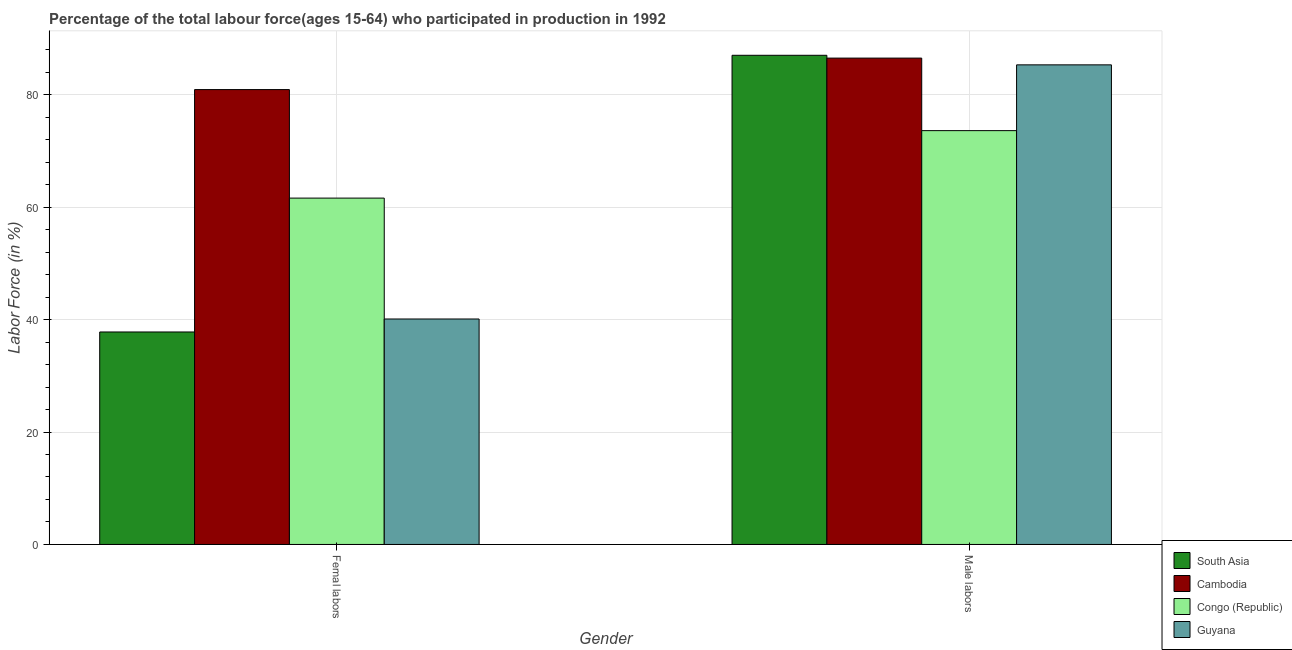How many different coloured bars are there?
Keep it short and to the point. 4. How many groups of bars are there?
Your response must be concise. 2. Are the number of bars on each tick of the X-axis equal?
Your response must be concise. Yes. How many bars are there on the 2nd tick from the left?
Your answer should be very brief. 4. What is the label of the 2nd group of bars from the left?
Give a very brief answer. Male labors. What is the percentage of female labor force in South Asia?
Offer a very short reply. 37.79. Across all countries, what is the maximum percentage of male labour force?
Offer a terse response. 87. Across all countries, what is the minimum percentage of female labor force?
Keep it short and to the point. 37.79. In which country was the percentage of male labour force maximum?
Provide a short and direct response. South Asia. In which country was the percentage of female labor force minimum?
Ensure brevity in your answer.  South Asia. What is the total percentage of male labour force in the graph?
Keep it short and to the point. 332.4. What is the difference between the percentage of male labour force in Congo (Republic) and that in Cambodia?
Provide a short and direct response. -12.9. What is the difference between the percentage of female labor force in Cambodia and the percentage of male labour force in Guyana?
Your answer should be very brief. -4.4. What is the average percentage of male labour force per country?
Give a very brief answer. 83.1. What is the difference between the percentage of male labour force and percentage of female labor force in South Asia?
Ensure brevity in your answer.  49.21. What is the ratio of the percentage of female labor force in Congo (Republic) to that in Guyana?
Give a very brief answer. 1.54. Is the percentage of male labour force in South Asia less than that in Cambodia?
Your answer should be very brief. No. In how many countries, is the percentage of male labour force greater than the average percentage of male labour force taken over all countries?
Offer a very short reply. 3. What does the 3rd bar from the left in Femal labors represents?
Ensure brevity in your answer.  Congo (Republic). What does the 2nd bar from the right in Femal labors represents?
Your answer should be very brief. Congo (Republic). Are all the bars in the graph horizontal?
Provide a short and direct response. No. Are the values on the major ticks of Y-axis written in scientific E-notation?
Offer a terse response. No. Does the graph contain any zero values?
Ensure brevity in your answer.  No. How many legend labels are there?
Give a very brief answer. 4. How are the legend labels stacked?
Provide a succinct answer. Vertical. What is the title of the graph?
Provide a succinct answer. Percentage of the total labour force(ages 15-64) who participated in production in 1992. Does "Caribbean small states" appear as one of the legend labels in the graph?
Keep it short and to the point. No. What is the label or title of the Y-axis?
Keep it short and to the point. Labor Force (in %). What is the Labor Force (in %) of South Asia in Femal labors?
Your answer should be compact. 37.79. What is the Labor Force (in %) of Cambodia in Femal labors?
Give a very brief answer. 80.9. What is the Labor Force (in %) in Congo (Republic) in Femal labors?
Your response must be concise. 61.6. What is the Labor Force (in %) in Guyana in Femal labors?
Make the answer very short. 40.1. What is the Labor Force (in %) of South Asia in Male labors?
Provide a short and direct response. 87. What is the Labor Force (in %) of Cambodia in Male labors?
Offer a terse response. 86.5. What is the Labor Force (in %) in Congo (Republic) in Male labors?
Provide a short and direct response. 73.6. What is the Labor Force (in %) of Guyana in Male labors?
Give a very brief answer. 85.3. Across all Gender, what is the maximum Labor Force (in %) in South Asia?
Offer a terse response. 87. Across all Gender, what is the maximum Labor Force (in %) in Cambodia?
Your response must be concise. 86.5. Across all Gender, what is the maximum Labor Force (in %) of Congo (Republic)?
Provide a succinct answer. 73.6. Across all Gender, what is the maximum Labor Force (in %) of Guyana?
Your response must be concise. 85.3. Across all Gender, what is the minimum Labor Force (in %) of South Asia?
Make the answer very short. 37.79. Across all Gender, what is the minimum Labor Force (in %) of Cambodia?
Offer a terse response. 80.9. Across all Gender, what is the minimum Labor Force (in %) of Congo (Republic)?
Give a very brief answer. 61.6. Across all Gender, what is the minimum Labor Force (in %) in Guyana?
Keep it short and to the point. 40.1. What is the total Labor Force (in %) of South Asia in the graph?
Provide a succinct answer. 124.79. What is the total Labor Force (in %) of Cambodia in the graph?
Provide a succinct answer. 167.4. What is the total Labor Force (in %) of Congo (Republic) in the graph?
Give a very brief answer. 135.2. What is the total Labor Force (in %) in Guyana in the graph?
Your answer should be compact. 125.4. What is the difference between the Labor Force (in %) in South Asia in Femal labors and that in Male labors?
Your answer should be compact. -49.21. What is the difference between the Labor Force (in %) in Congo (Republic) in Femal labors and that in Male labors?
Offer a terse response. -12. What is the difference between the Labor Force (in %) in Guyana in Femal labors and that in Male labors?
Keep it short and to the point. -45.2. What is the difference between the Labor Force (in %) of South Asia in Femal labors and the Labor Force (in %) of Cambodia in Male labors?
Keep it short and to the point. -48.71. What is the difference between the Labor Force (in %) of South Asia in Femal labors and the Labor Force (in %) of Congo (Republic) in Male labors?
Offer a very short reply. -35.81. What is the difference between the Labor Force (in %) in South Asia in Femal labors and the Labor Force (in %) in Guyana in Male labors?
Your response must be concise. -47.51. What is the difference between the Labor Force (in %) in Congo (Republic) in Femal labors and the Labor Force (in %) in Guyana in Male labors?
Offer a very short reply. -23.7. What is the average Labor Force (in %) in South Asia per Gender?
Your answer should be compact. 62.4. What is the average Labor Force (in %) of Cambodia per Gender?
Give a very brief answer. 83.7. What is the average Labor Force (in %) of Congo (Republic) per Gender?
Ensure brevity in your answer.  67.6. What is the average Labor Force (in %) of Guyana per Gender?
Offer a very short reply. 62.7. What is the difference between the Labor Force (in %) of South Asia and Labor Force (in %) of Cambodia in Femal labors?
Provide a short and direct response. -43.11. What is the difference between the Labor Force (in %) of South Asia and Labor Force (in %) of Congo (Republic) in Femal labors?
Make the answer very short. -23.81. What is the difference between the Labor Force (in %) of South Asia and Labor Force (in %) of Guyana in Femal labors?
Ensure brevity in your answer.  -2.31. What is the difference between the Labor Force (in %) of Cambodia and Labor Force (in %) of Congo (Republic) in Femal labors?
Keep it short and to the point. 19.3. What is the difference between the Labor Force (in %) of Cambodia and Labor Force (in %) of Guyana in Femal labors?
Provide a short and direct response. 40.8. What is the difference between the Labor Force (in %) in Congo (Republic) and Labor Force (in %) in Guyana in Femal labors?
Provide a short and direct response. 21.5. What is the difference between the Labor Force (in %) of South Asia and Labor Force (in %) of Cambodia in Male labors?
Ensure brevity in your answer.  0.5. What is the difference between the Labor Force (in %) in South Asia and Labor Force (in %) in Congo (Republic) in Male labors?
Give a very brief answer. 13.4. What is the difference between the Labor Force (in %) of South Asia and Labor Force (in %) of Guyana in Male labors?
Offer a terse response. 1.7. What is the ratio of the Labor Force (in %) in South Asia in Femal labors to that in Male labors?
Your answer should be very brief. 0.43. What is the ratio of the Labor Force (in %) in Cambodia in Femal labors to that in Male labors?
Make the answer very short. 0.94. What is the ratio of the Labor Force (in %) in Congo (Republic) in Femal labors to that in Male labors?
Give a very brief answer. 0.84. What is the ratio of the Labor Force (in %) of Guyana in Femal labors to that in Male labors?
Make the answer very short. 0.47. What is the difference between the highest and the second highest Labor Force (in %) of South Asia?
Keep it short and to the point. 49.21. What is the difference between the highest and the second highest Labor Force (in %) in Cambodia?
Make the answer very short. 5.6. What is the difference between the highest and the second highest Labor Force (in %) in Guyana?
Ensure brevity in your answer.  45.2. What is the difference between the highest and the lowest Labor Force (in %) in South Asia?
Give a very brief answer. 49.21. What is the difference between the highest and the lowest Labor Force (in %) in Cambodia?
Provide a short and direct response. 5.6. What is the difference between the highest and the lowest Labor Force (in %) of Guyana?
Provide a succinct answer. 45.2. 